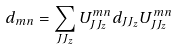<formula> <loc_0><loc_0><loc_500><loc_500>d _ { m n } = \sum _ { J J _ { z } } U ^ { m n } _ { J J _ { z } } d _ { J J _ { z } } U ^ { m n } _ { J J _ { z } }</formula> 